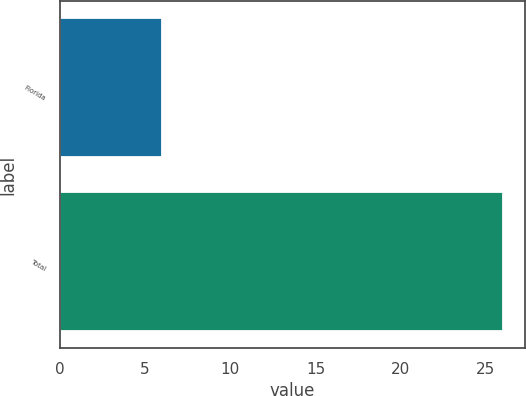Convert chart. <chart><loc_0><loc_0><loc_500><loc_500><bar_chart><fcel>Florida<fcel>Total<nl><fcel>6<fcel>26<nl></chart> 